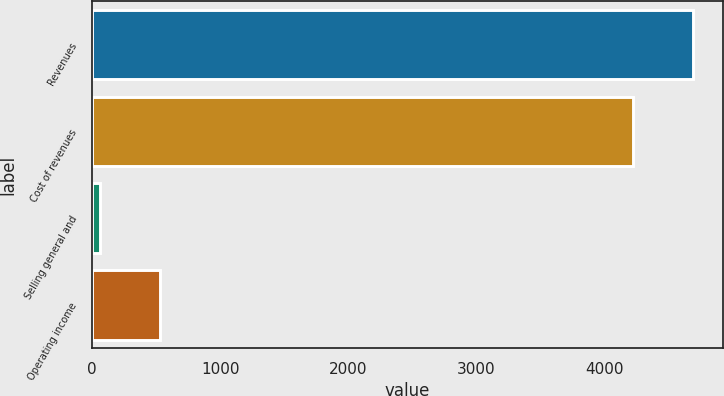Convert chart to OTSL. <chart><loc_0><loc_0><loc_500><loc_500><bar_chart><fcel>Revenues<fcel>Cost of revenues<fcel>Selling general and<fcel>Operating income<nl><fcel>4691.8<fcel>4230<fcel>65<fcel>526.8<nl></chart> 